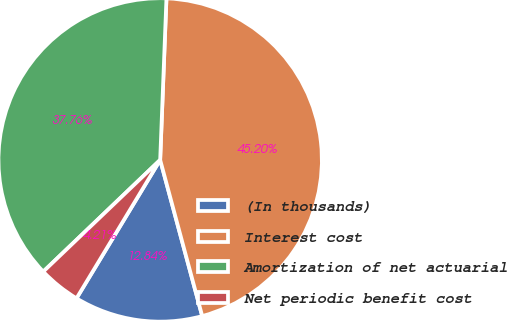<chart> <loc_0><loc_0><loc_500><loc_500><pie_chart><fcel>(In thousands)<fcel>Interest cost<fcel>Amortization of net actuarial<fcel>Net periodic benefit cost<nl><fcel>12.84%<fcel>45.2%<fcel>37.76%<fcel>4.21%<nl></chart> 